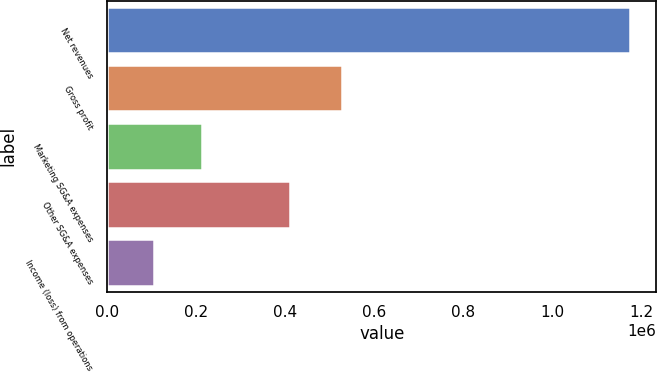Convert chart to OTSL. <chart><loc_0><loc_0><loc_500><loc_500><bar_chart><fcel>Net revenues<fcel>Gross profit<fcel>Marketing SG&A expenses<fcel>Other SG&A expenses<fcel>Income (loss) from operations<nl><fcel>1.17486e+06<fcel>526584<fcel>211873<fcel>411147<fcel>104875<nl></chart> 